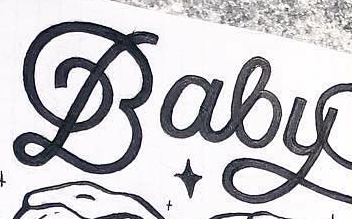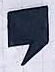Identify the words shown in these images in order, separated by a semicolon. Baby; , 